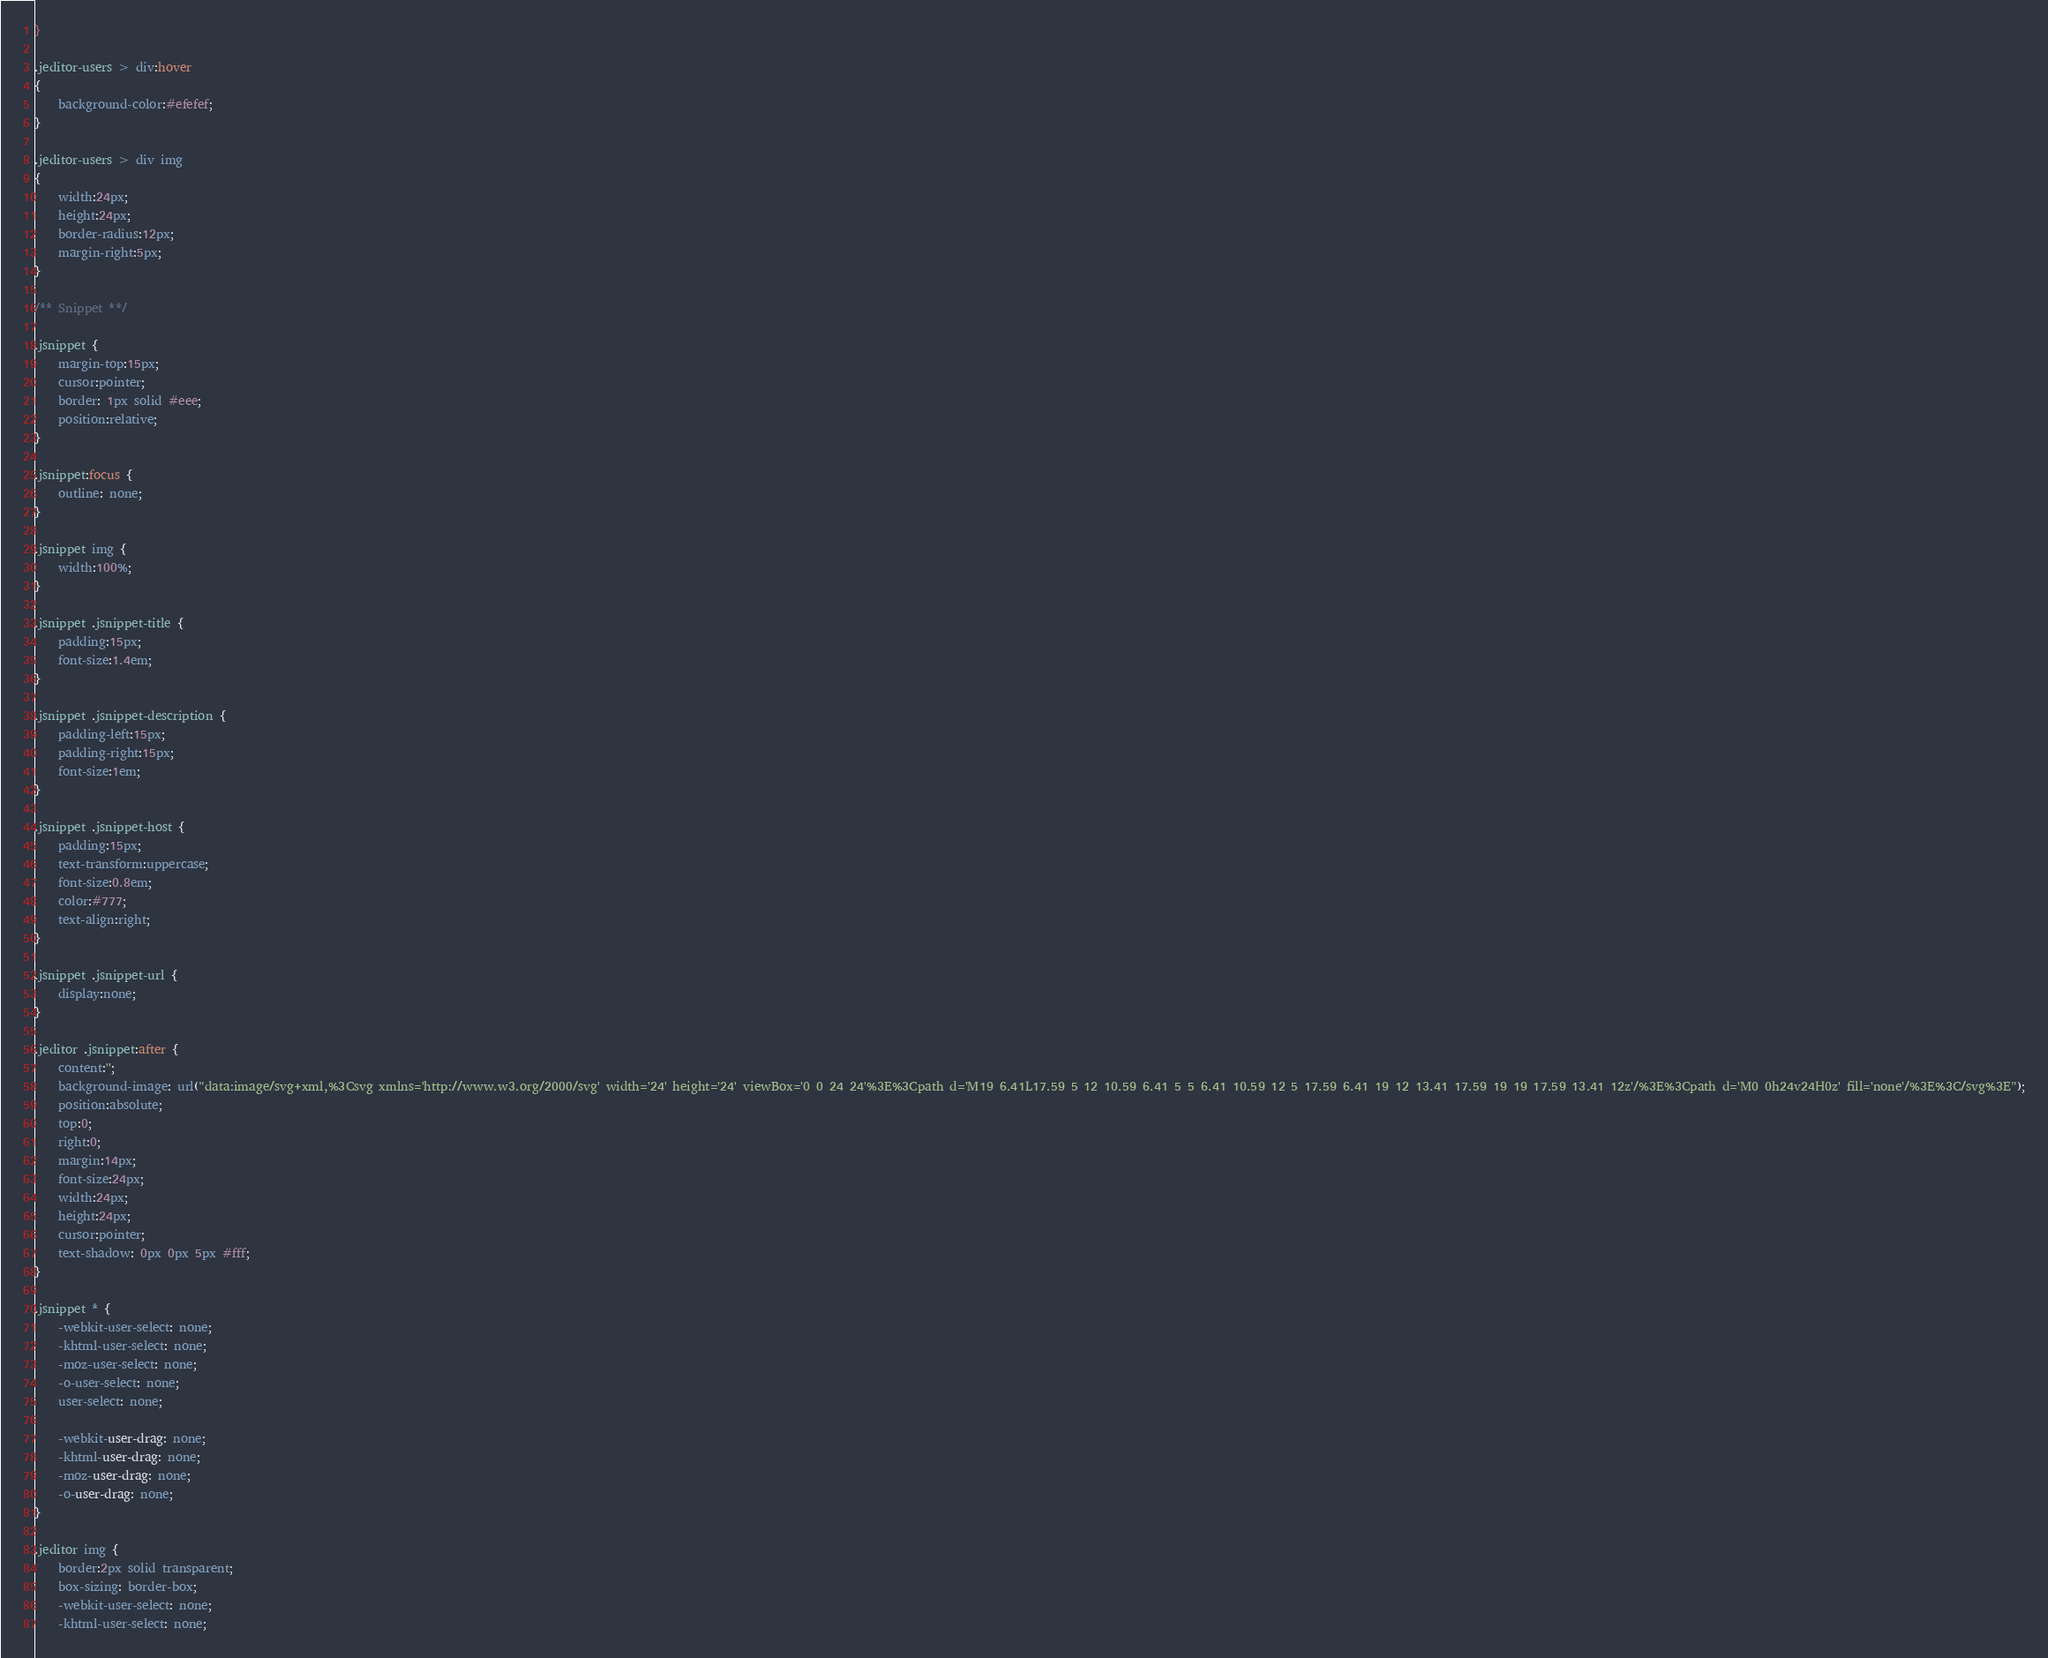Convert code to text. <code><loc_0><loc_0><loc_500><loc_500><_CSS_>}

.jeditor-users > div:hover
{
    background-color:#efefef;
}

.jeditor-users > div img
{
    width:24px;
    height:24px;
    border-radius:12px;
    margin-right:5px;
}

/** Snippet **/

.jsnippet {
    margin-top:15px;
    cursor:pointer;
    border: 1px solid #eee;
    position:relative;
}

.jsnippet:focus {
    outline: none;
}

.jsnippet img {
    width:100%;
}

.jsnippet .jsnippet-title {
    padding:15px;
    font-size:1.4em;
}

.jsnippet .jsnippet-description {
    padding-left:15px;
    padding-right:15px;
    font-size:1em;
}

.jsnippet .jsnippet-host {
    padding:15px;
    text-transform:uppercase;
    font-size:0.8em;
    color:#777;
    text-align:right;
}

.jsnippet .jsnippet-url {
    display:none;
}

.jeditor .jsnippet:after {
    content:'';
    background-image: url("data:image/svg+xml,%3Csvg xmlns='http://www.w3.org/2000/svg' width='24' height='24' viewBox='0 0 24 24'%3E%3Cpath d='M19 6.41L17.59 5 12 10.59 6.41 5 5 6.41 10.59 12 5 17.59 6.41 19 12 13.41 17.59 19 19 17.59 13.41 12z'/%3E%3Cpath d='M0 0h24v24H0z' fill='none'/%3E%3C/svg%3E");
    position:absolute;
    top:0;
    right:0;
    margin:14px;
    font-size:24px;
    width:24px;
    height:24px;
    cursor:pointer;
    text-shadow: 0px 0px 5px #fff;
}

.jsnippet * {
    -webkit-user-select: none;
    -khtml-user-select: none;
    -moz-user-select: none;
    -o-user-select: none;
    user-select: none;

    -webkit-user-drag: none;
    -khtml-user-drag: none;
    -moz-user-drag: none;
    -o-user-drag: none;
}

.jeditor img {
    border:2px solid transparent;
    box-sizing: border-box;
    -webkit-user-select: none;
    -khtml-user-select: none;</code> 